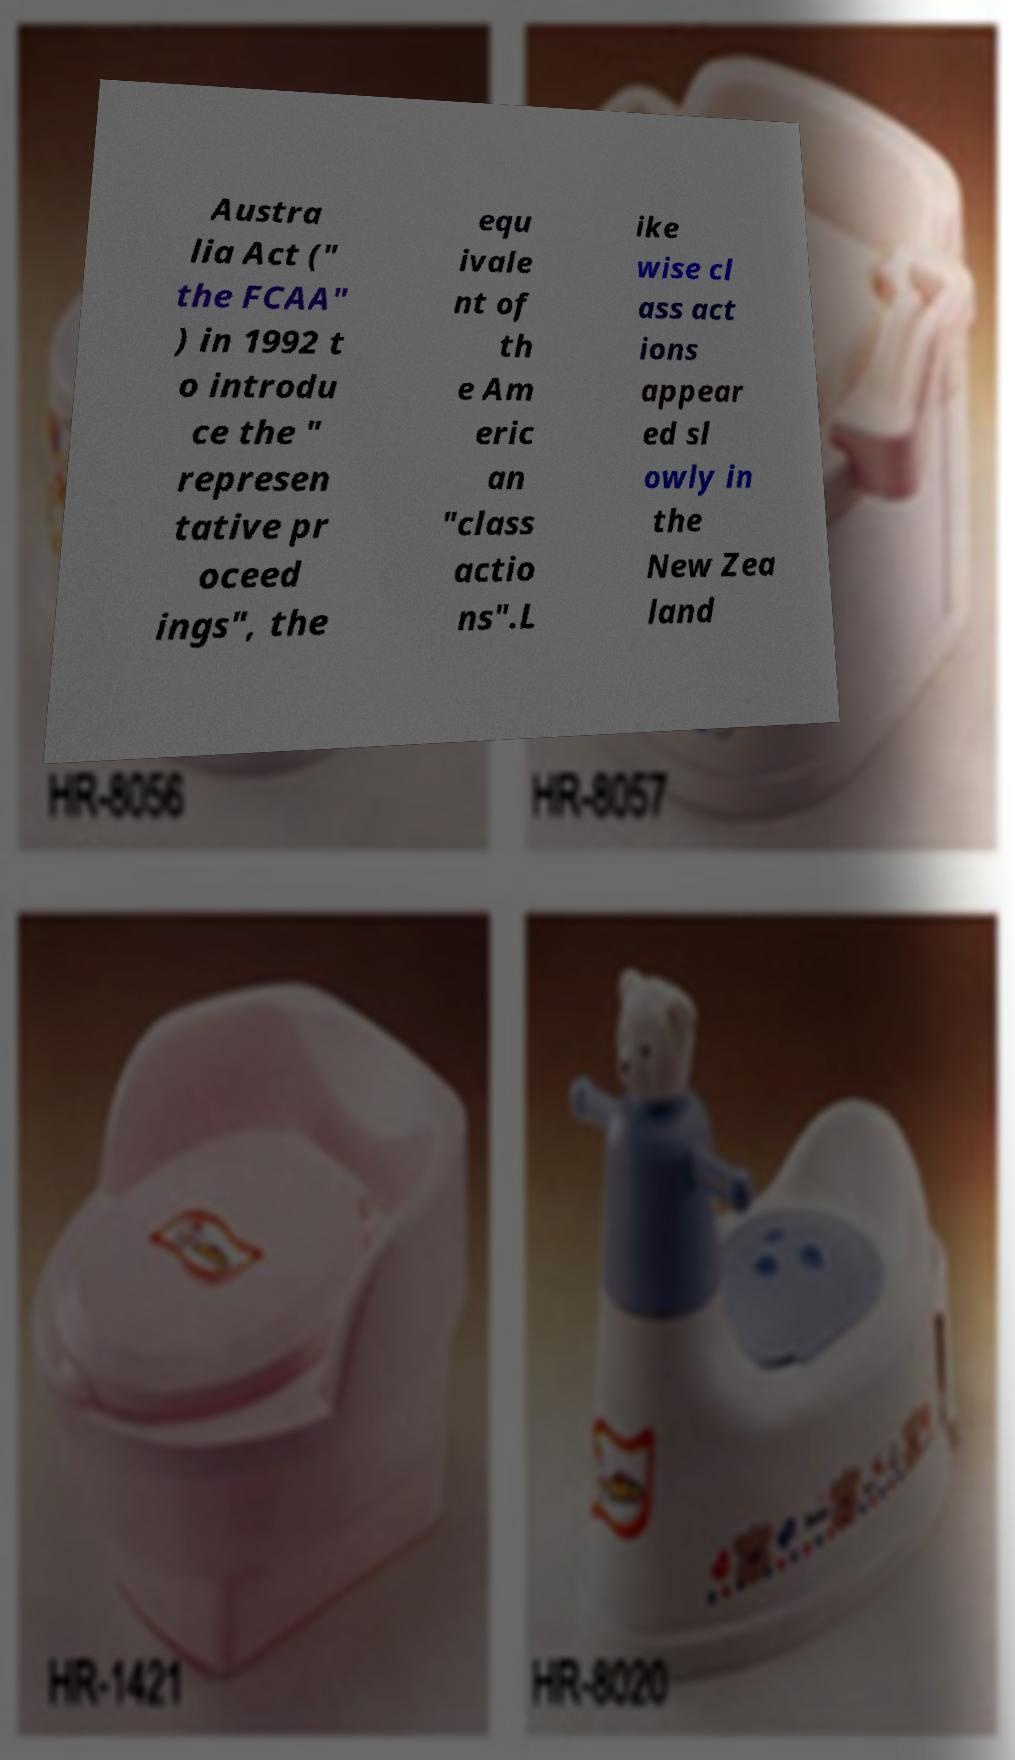Can you accurately transcribe the text from the provided image for me? Austra lia Act (" the FCAA" ) in 1992 t o introdu ce the " represen tative pr oceed ings", the equ ivale nt of th e Am eric an "class actio ns".L ike wise cl ass act ions appear ed sl owly in the New Zea land 